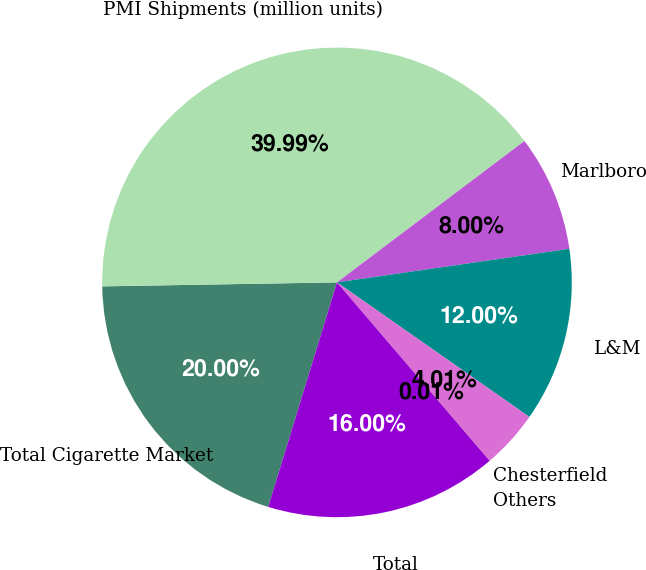Convert chart. <chart><loc_0><loc_0><loc_500><loc_500><pie_chart><fcel>Total Cigarette Market<fcel>PMI Shipments (million units)<fcel>Marlboro<fcel>L&M<fcel>Chesterfield<fcel>Others<fcel>Total<nl><fcel>20.0%<fcel>39.99%<fcel>8.0%<fcel>12.0%<fcel>4.01%<fcel>0.01%<fcel>16.0%<nl></chart> 